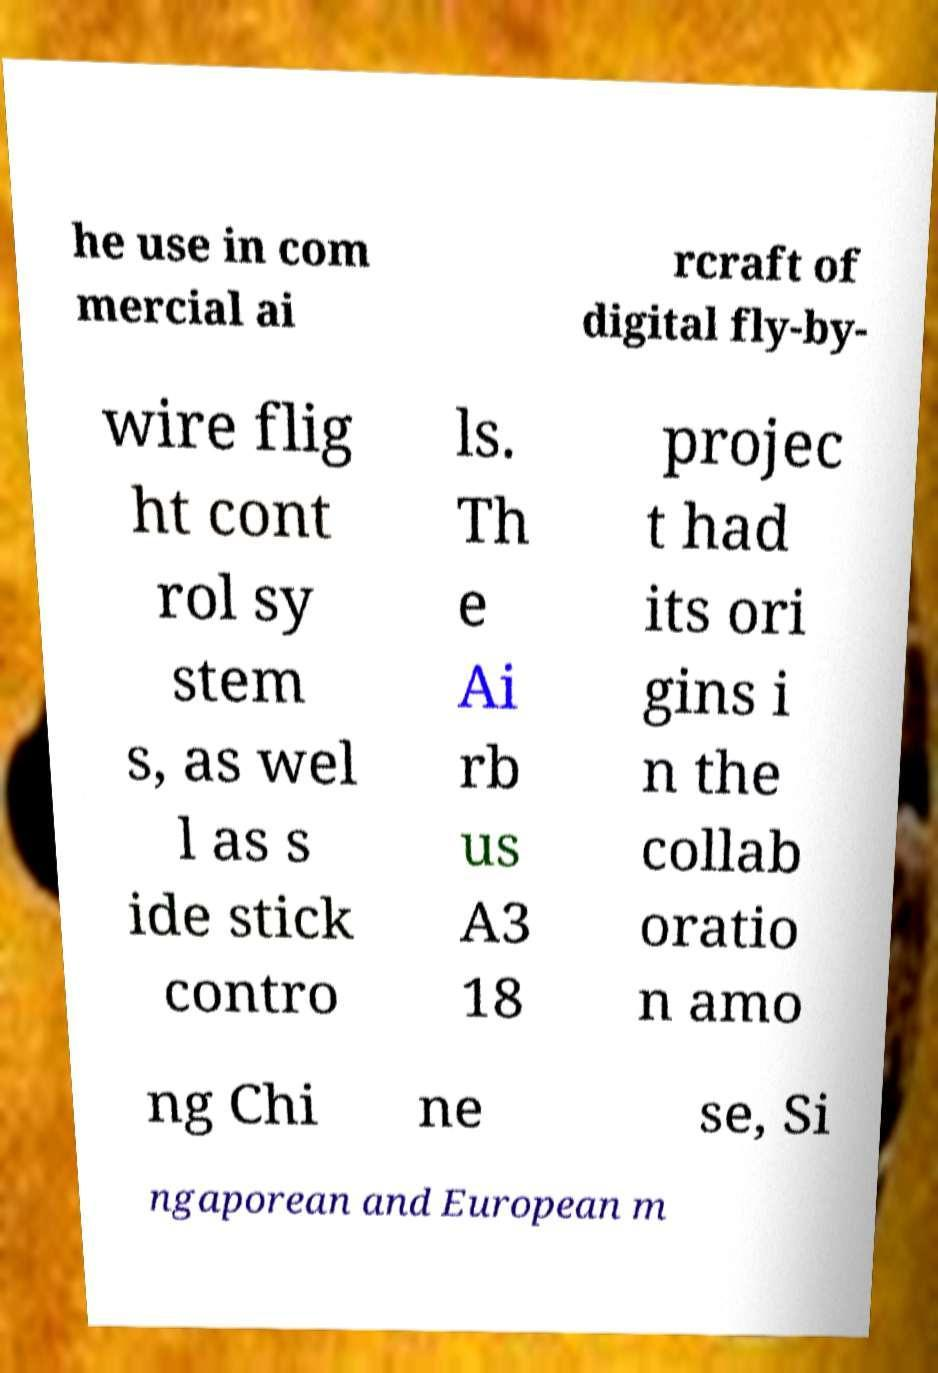I need the written content from this picture converted into text. Can you do that? he use in com mercial ai rcraft of digital fly-by- wire flig ht cont rol sy stem s, as wel l as s ide stick contro ls. Th e Ai rb us A3 18 projec t had its ori gins i n the collab oratio n amo ng Chi ne se, Si ngaporean and European m 